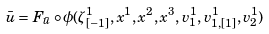Convert formula to latex. <formula><loc_0><loc_0><loc_500><loc_500>\bar { u } = F _ { \bar { u } } \circ \phi ( \zeta _ { [ - 1 ] } ^ { 1 } , x ^ { 1 } , x ^ { 2 } , x ^ { 3 } , v _ { 1 } ^ { 1 } , v _ { 1 , [ 1 ] } ^ { 1 } , v _ { 2 } ^ { 1 } )</formula> 